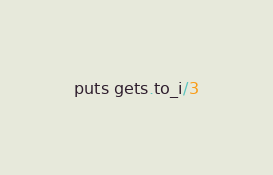Convert code to text. <code><loc_0><loc_0><loc_500><loc_500><_Ruby_>puts gets.to_i/3</code> 